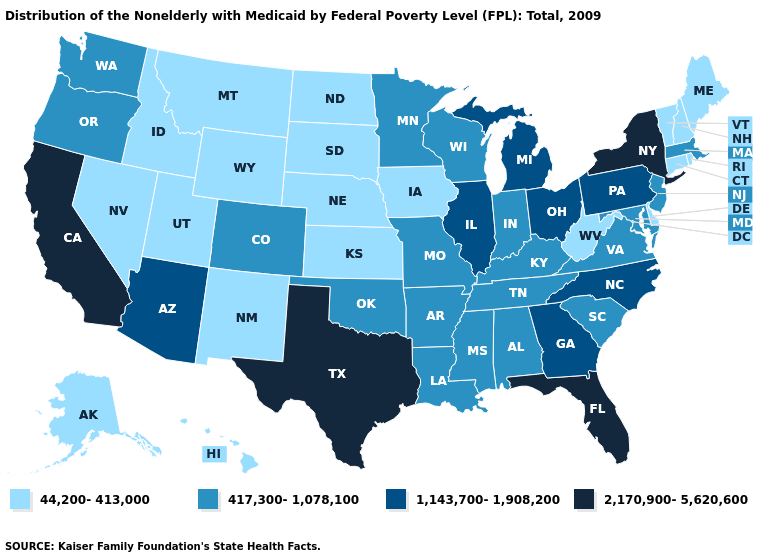Does Ohio have the highest value in the MidWest?
Concise answer only. Yes. Does Kansas have the lowest value in the USA?
Write a very short answer. Yes. Name the states that have a value in the range 1,143,700-1,908,200?
Quick response, please. Arizona, Georgia, Illinois, Michigan, North Carolina, Ohio, Pennsylvania. What is the value of Indiana?
Keep it brief. 417,300-1,078,100. What is the highest value in the MidWest ?
Quick response, please. 1,143,700-1,908,200. Does Florida have the highest value in the USA?
Give a very brief answer. Yes. Does New Hampshire have the highest value in the Northeast?
Give a very brief answer. No. What is the value of Missouri?
Answer briefly. 417,300-1,078,100. Name the states that have a value in the range 1,143,700-1,908,200?
Keep it brief. Arizona, Georgia, Illinois, Michigan, North Carolina, Ohio, Pennsylvania. What is the value of Nebraska?
Concise answer only. 44,200-413,000. Does New York have the highest value in the Northeast?
Give a very brief answer. Yes. Does Kansas have the lowest value in the MidWest?
Answer briefly. Yes. Which states hav the highest value in the South?
Write a very short answer. Florida, Texas. Does Minnesota have a lower value than Mississippi?
Give a very brief answer. No. Does Vermont have the same value as Maine?
Write a very short answer. Yes. 